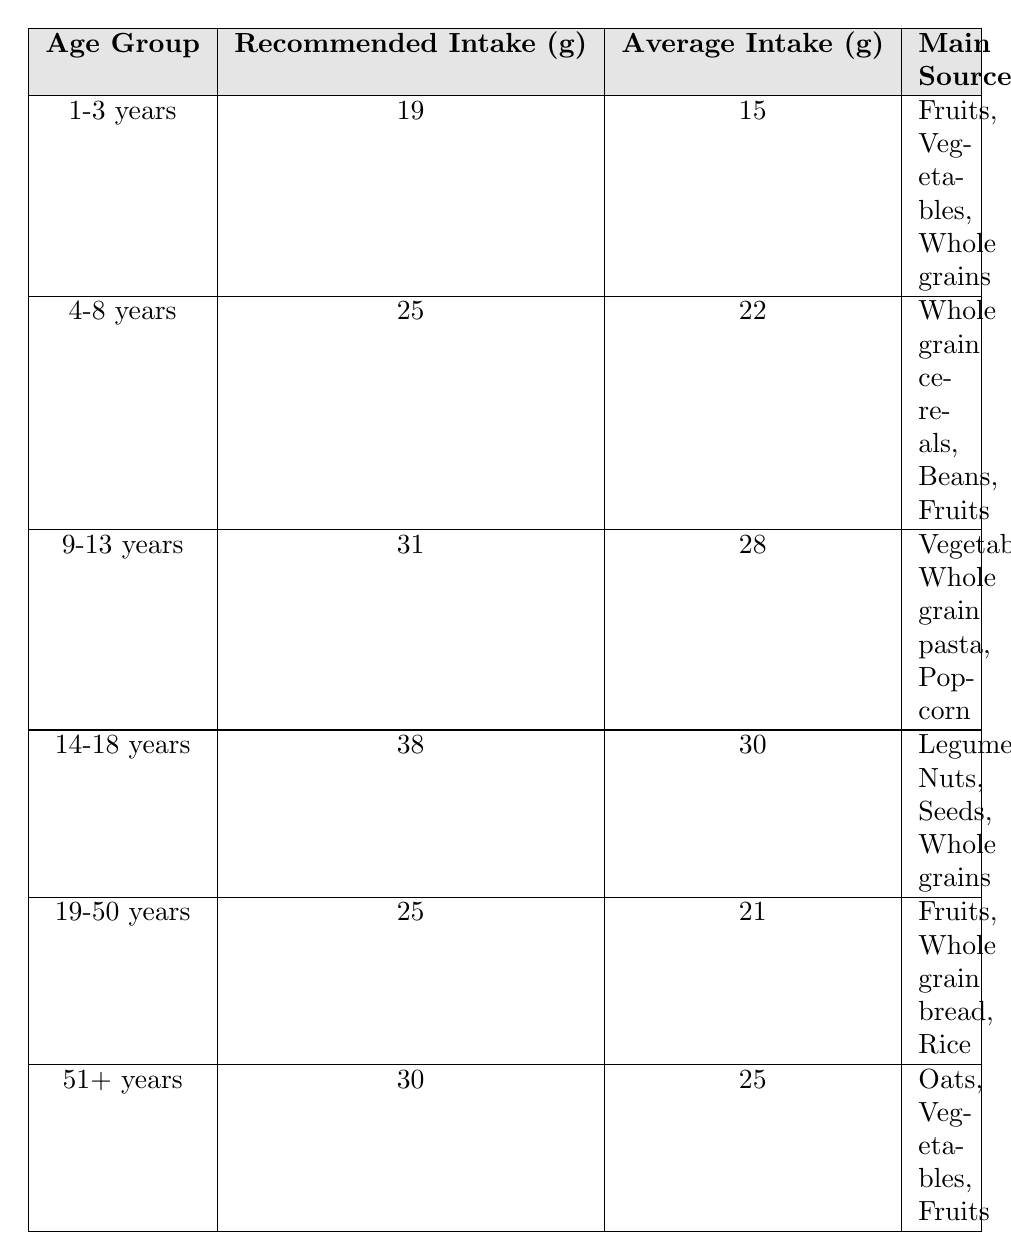What is the average dietary fiber intake for children aged 1-3 years? The table shows that the average intake of dietary fiber for the age group 1-3 years is 15 grams.
Answer: 15 grams What is the recommended dietary fiber intake for teenagers aged 14-18 years? According to the table, the recommended intake for the age group 14-18 years is 38 grams.
Answer: 38 grams Which age group has the lowest average dietary fiber intake? The age group 1-3 years has the lowest average dietary fiber intake at 15 grams.
Answer: 1-3 years What is the difference between the recommended intake and the average intake for individuals aged 19-50 years? The recommended intake for 19-50 years is 25 grams, and the average intake is 21 grams. The difference is 25 - 21 = 4 grams.
Answer: 4 grams Is the average dietary fiber intake for adults aged 51 years and older greater than 20 grams? Yes, the average intake for this age group is 25 grams, which is greater than 20 grams.
Answer: Yes What is the total recommended dietary fiber intake for all age groups listed in the table? We sum the recommended intakes: 19 + 25 + 31 + 38 + 25 + 30 = 168 grams. Thus, the total recommended intake for all age groups is 168 grams.
Answer: 168 grams What sources of dietary fiber are recommended for children aged 4-8 years? The table lists whole grain cereals, beans, and fruits as the main sources for the age group 4-8 years.
Answer: Whole grain cereals, beans, fruits Which age group has the highest average dietary fiber intake? The age group 14-18 years has the highest average intake at 30 grams.
Answer: 14-18 years If a person is in the 9-13 years age group, how much dietary fiber do they need to increase their intake to meet the recommended level? The recommended intake for 9-13 years is 31 grams, and the average intake is 28 grams. They need to increase their intake by 31 - 28 = 3 grams.
Answer: 3 grams Are the average fiber intakes for all age groups below their corresponding recommended intakes? No, in the age group 51+ years, the average intake (25 grams) is below the recommended intake (30 grams), but other age groups have lower average intakes.
Answer: No 